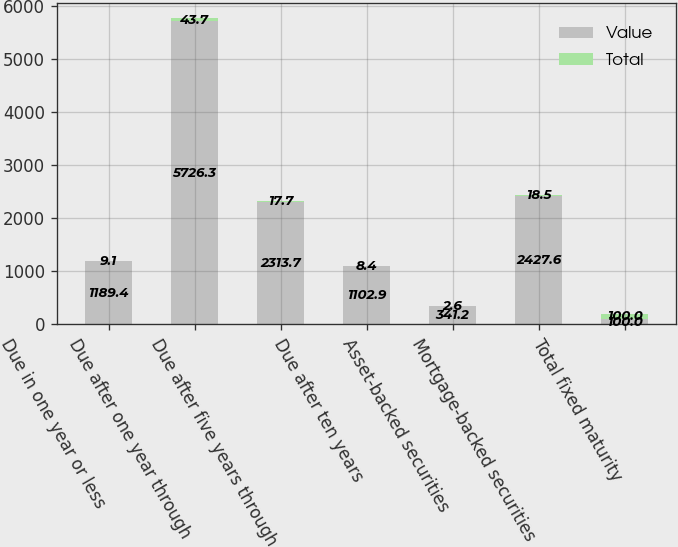Convert chart to OTSL. <chart><loc_0><loc_0><loc_500><loc_500><stacked_bar_chart><ecel><fcel>Due in one year or less<fcel>Due after one year through<fcel>Due after five years through<fcel>Due after ten years<fcel>Asset-backed securities<fcel>Mortgage-backed securities<fcel>Total fixed maturity<nl><fcel>Value<fcel>1189.4<fcel>5726.3<fcel>2313.7<fcel>1102.9<fcel>341.2<fcel>2427.6<fcel>100<nl><fcel>Total<fcel>9.1<fcel>43.7<fcel>17.7<fcel>8.4<fcel>2.6<fcel>18.5<fcel>100<nl></chart> 